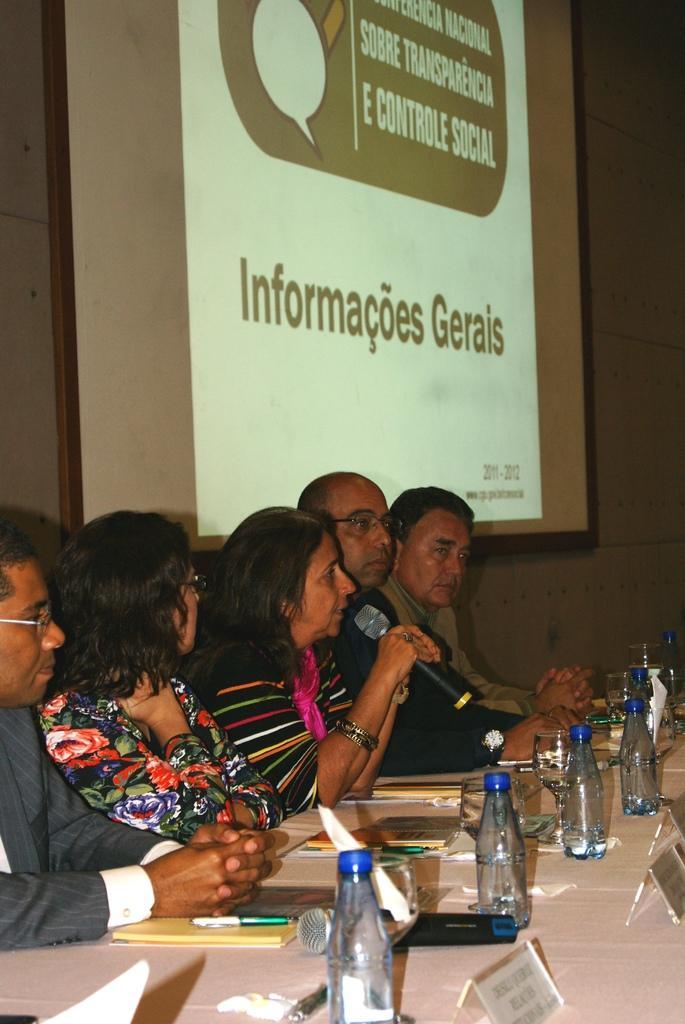Describe this image in one or two sentences. As we can see in the image there is a screen, few people sitting on chairs and there is a table. On table there are bottles, glasses and books. The woman who is sitting over here is talking on mic. 